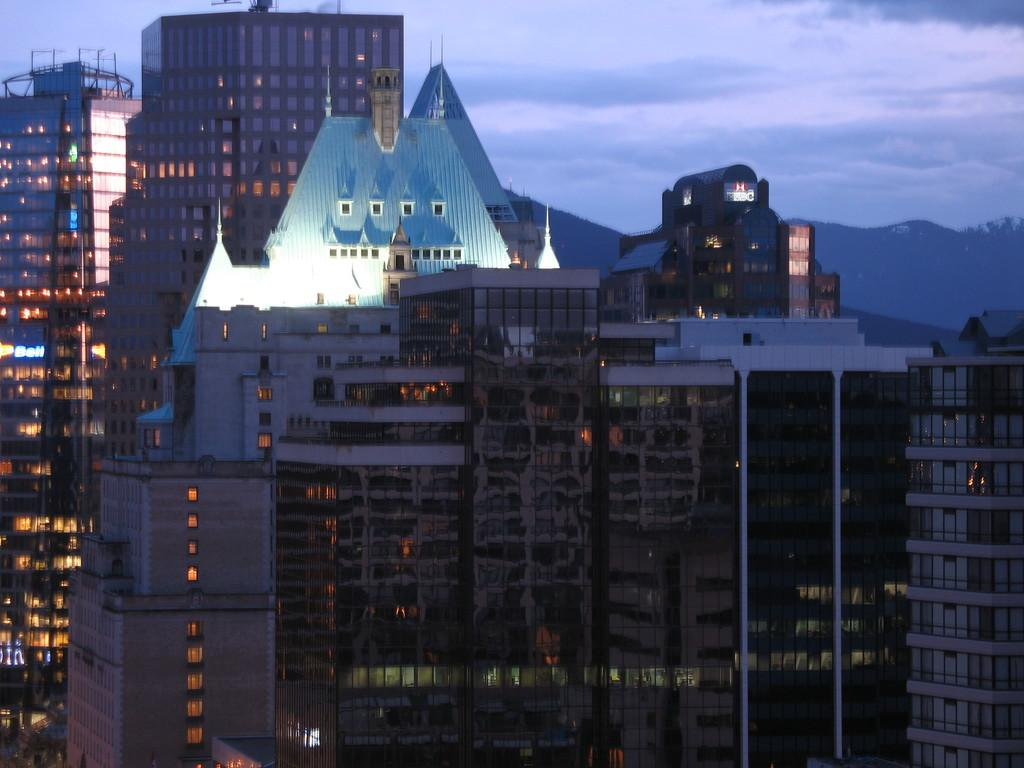What type of structures can be seen in the image? There are many buildings in the image. What can be seen in the background of the image? There are trees and mountains in the background of the image. What is visible at the top of the image? The sky is visible at the top of the image. What can be observed in the sky? Clouds are present in the sky. What type of scissors can be seen cutting the trees in the image? There are no scissors present in the image, and the trees are not being cut. 